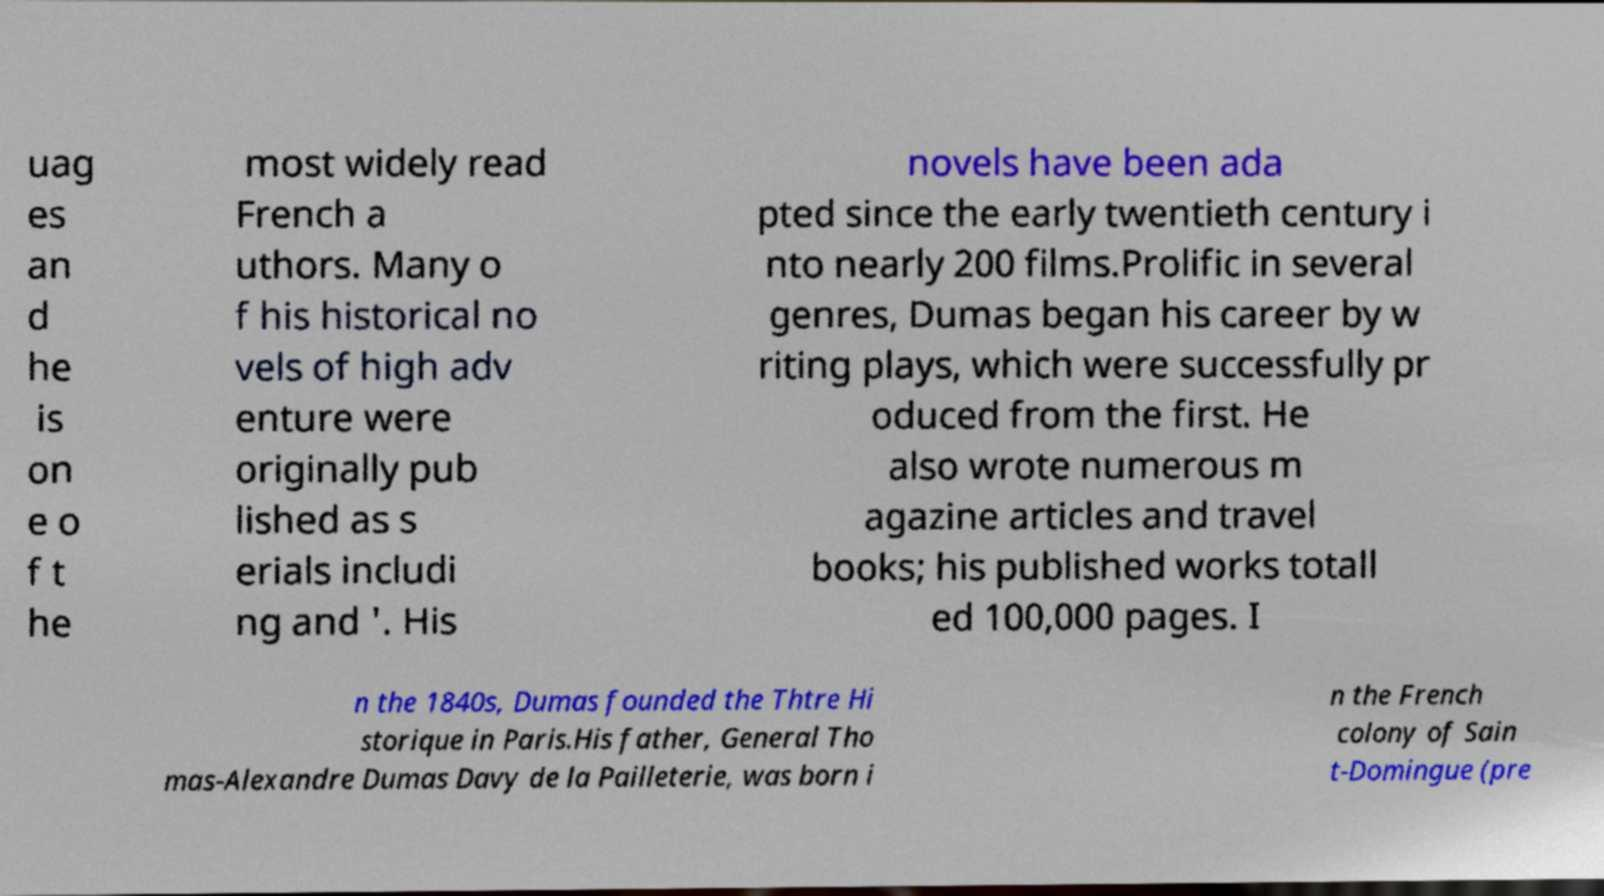Can you accurately transcribe the text from the provided image for me? uag es an d he is on e o f t he most widely read French a uthors. Many o f his historical no vels of high adv enture were originally pub lished as s erials includi ng and '. His novels have been ada pted since the early twentieth century i nto nearly 200 films.Prolific in several genres, Dumas began his career by w riting plays, which were successfully pr oduced from the first. He also wrote numerous m agazine articles and travel books; his published works totall ed 100,000 pages. I n the 1840s, Dumas founded the Thtre Hi storique in Paris.His father, General Tho mas-Alexandre Dumas Davy de la Pailleterie, was born i n the French colony of Sain t-Domingue (pre 